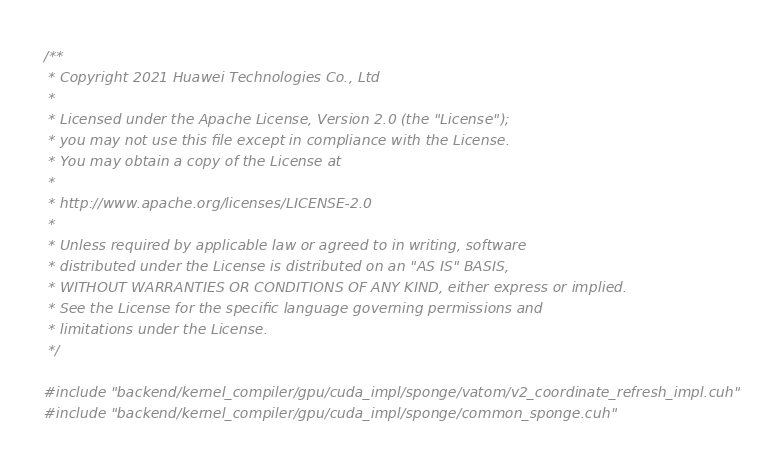<code> <loc_0><loc_0><loc_500><loc_500><_Cuda_>/**
 * Copyright 2021 Huawei Technologies Co., Ltd
 *
 * Licensed under the Apache License, Version 2.0 (the "License");
 * you may not use this file except in compliance with the License.
 * You may obtain a copy of the License at
 *
 * http://www.apache.org/licenses/LICENSE-2.0
 *
 * Unless required by applicable law or agreed to in writing, software
 * distributed under the License is distributed on an "AS IS" BASIS,
 * WITHOUT WARRANTIES OR CONDITIONS OF ANY KIND, either express or implied.
 * See the License for the specific language governing permissions and
 * limitations under the License.
 */

#include "backend/kernel_compiler/gpu/cuda_impl/sponge/vatom/v2_coordinate_refresh_impl.cuh"
#include "backend/kernel_compiler/gpu/cuda_impl/sponge/common_sponge.cuh"
</code> 